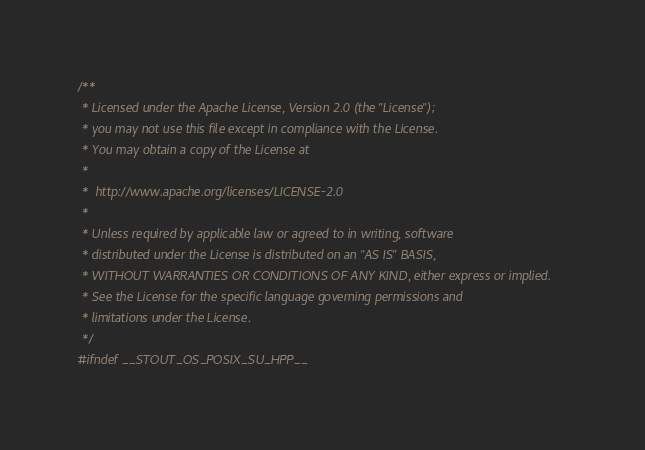<code> <loc_0><loc_0><loc_500><loc_500><_C++_>/**
 * Licensed under the Apache License, Version 2.0 (the "License");
 * you may not use this file except in compliance with the License.
 * You may obtain a copy of the License at
 *
 *  http://www.apache.org/licenses/LICENSE-2.0
 *
 * Unless required by applicable law or agreed to in writing, software
 * distributed under the License is distributed on an "AS IS" BASIS,
 * WITHOUT WARRANTIES OR CONDITIONS OF ANY KIND, either express or implied.
 * See the License for the specific language governing permissions and
 * limitations under the License.
 */
#ifndef __STOUT_OS_POSIX_SU_HPP__</code> 